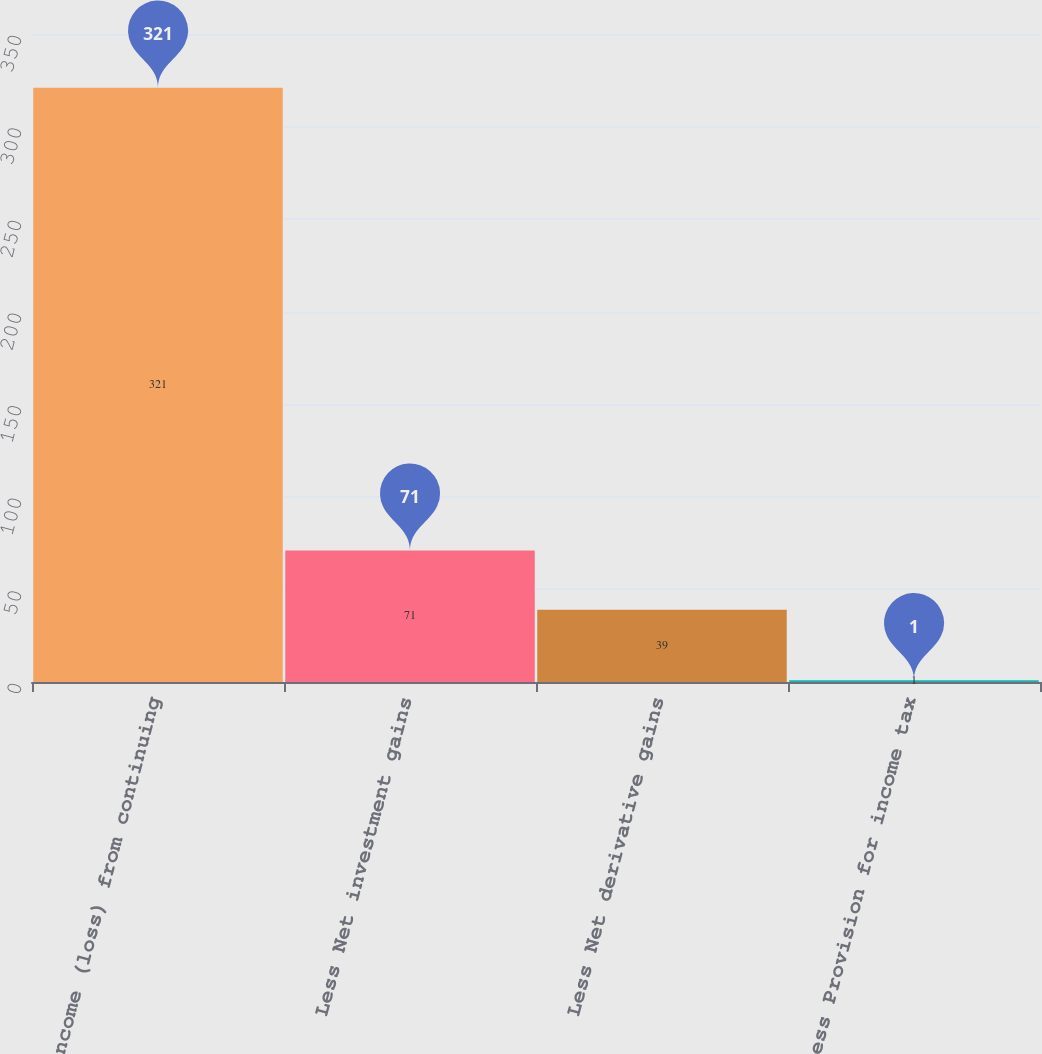<chart> <loc_0><loc_0><loc_500><loc_500><bar_chart><fcel>Income (loss) from continuing<fcel>Less Net investment gains<fcel>Less Net derivative gains<fcel>Less Provision for income tax<nl><fcel>321<fcel>71<fcel>39<fcel>1<nl></chart> 